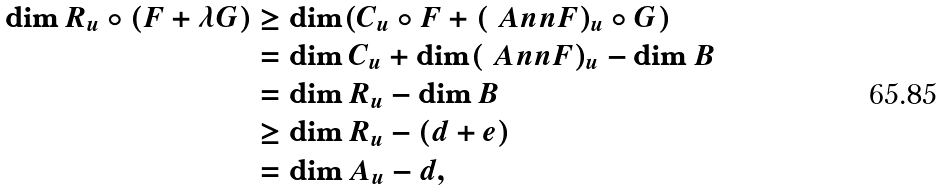<formula> <loc_0><loc_0><loc_500><loc_500>\dim R _ { u } \circ ( F + \lambda G ) & \geq \dim ( C _ { u } \circ F + ( \ A n n F ) _ { u } \circ G ) \\ & = \dim C _ { u } + \dim ( \ A n n F ) _ { u } - \dim B \\ & = \dim R _ { u } - \dim B \\ & \geq \dim R _ { u } - ( d + e ) \\ & = \dim A _ { u } - d ,</formula> 